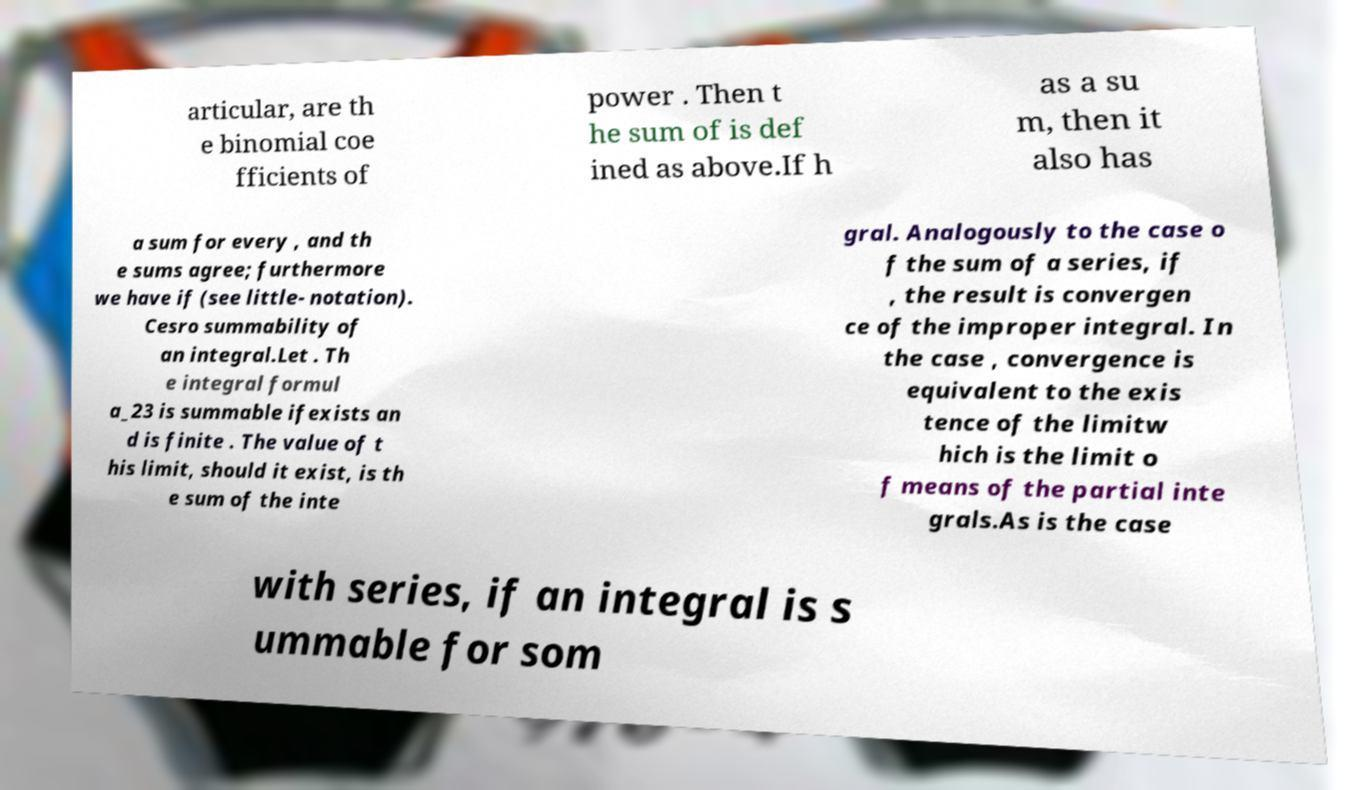What messages or text are displayed in this image? I need them in a readable, typed format. articular, are th e binomial coe fficients of power . Then t he sum of is def ined as above.If h as a su m, then it also has a sum for every , and th e sums agree; furthermore we have if (see little- notation). Cesro summability of an integral.Let . Th e integral formul a_23 is summable ifexists an d is finite . The value of t his limit, should it exist, is th e sum of the inte gral. Analogously to the case o f the sum of a series, if , the result is convergen ce of the improper integral. In the case , convergence is equivalent to the exis tence of the limitw hich is the limit o f means of the partial inte grals.As is the case with series, if an integral is s ummable for som 